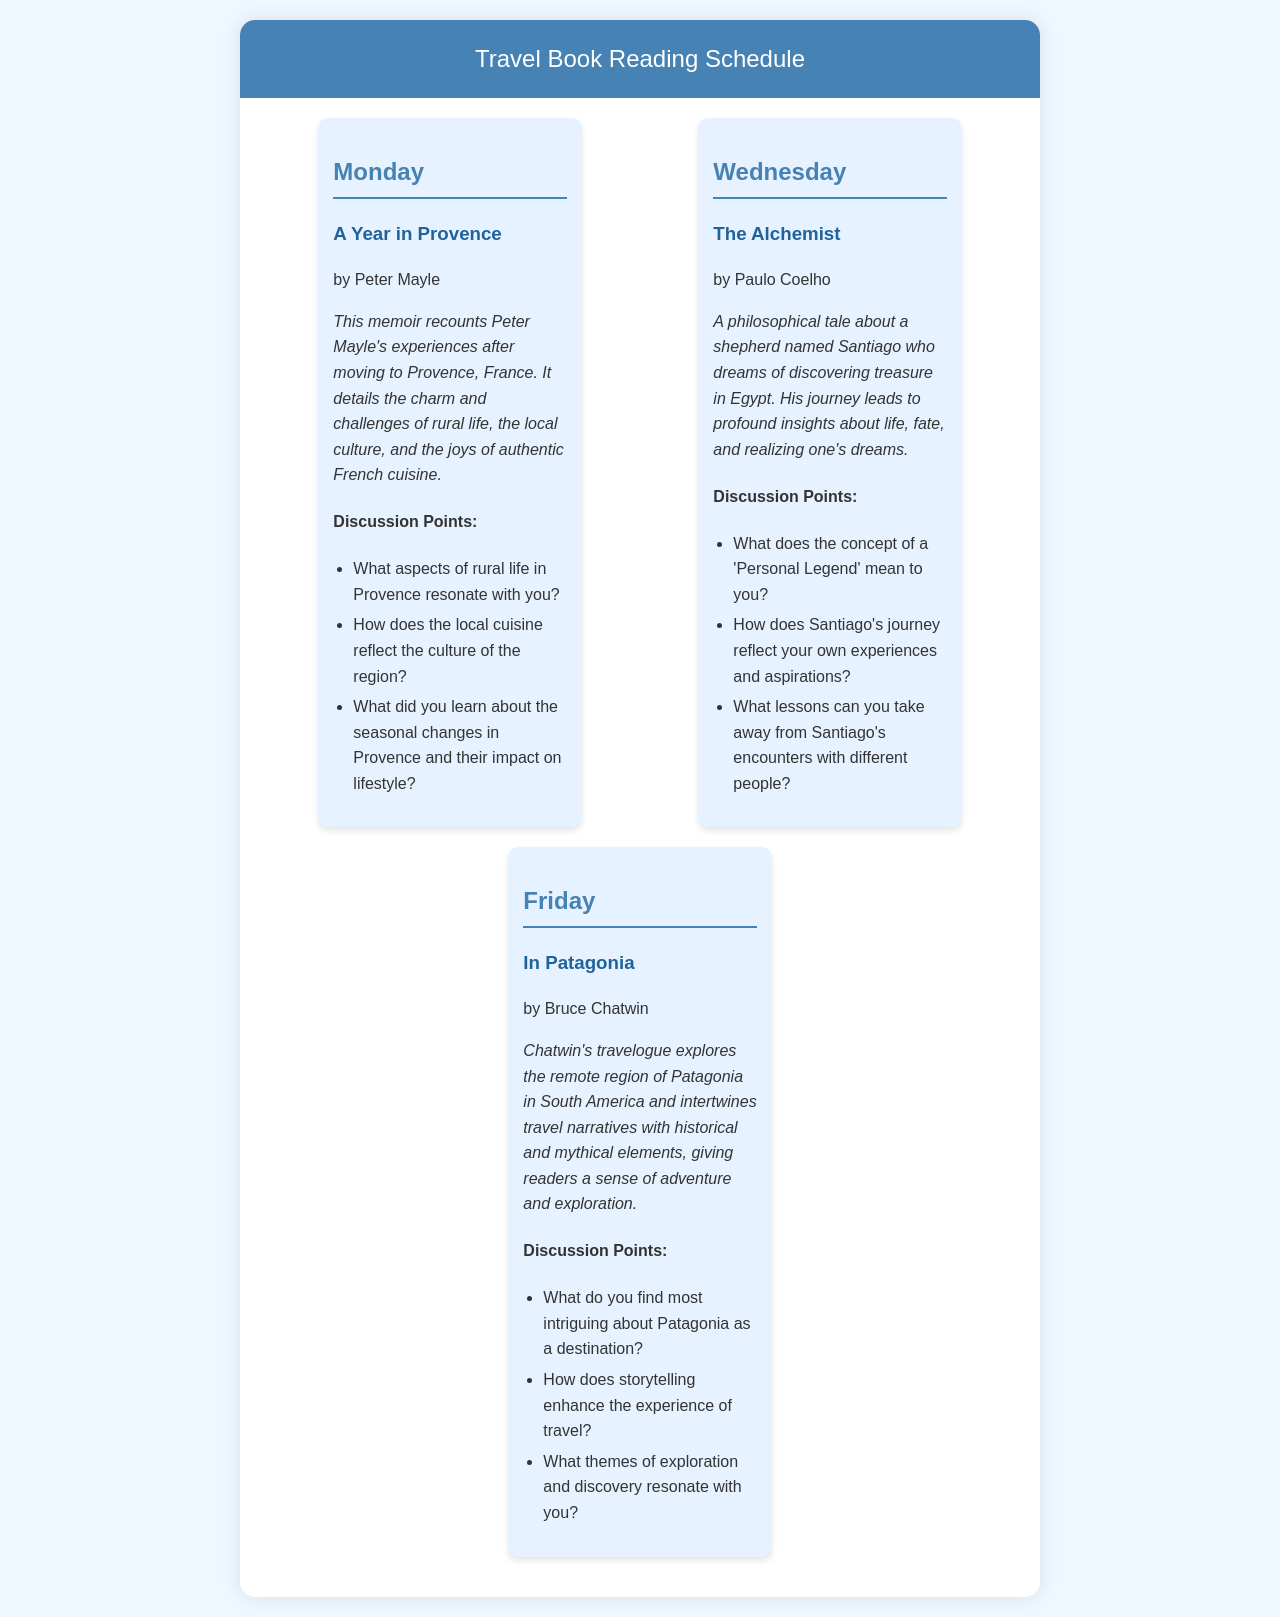What is the title of the book read on Monday? The title of the book is mentioned in the Monday section of the document.
Answer: A Year in Provence Who is the author of "The Alchemist"? The author is specified right under the title of the book in the Wednesday section.
Answer: Paulo Coelho What region does "In Patagonia" explore? The region is identified within the summary of the book in the Friday section.
Answer: Patagonia How many discussion points are provided for each book? The document lists the discussion points under each book section consistently.
Answer: Three What is the key theme discussed in "The Alchemist"? The key theme is mentioned in the summary and relates to the main character's journey.
Answer: Personal Legend Which day features a memoir about rural France? The specific day is indicated in the schedule with the corresponding book title.
Answer: Monday What does the summary of "In Patagonia" include? The summary provides insights into the elements that make up the travel narrative.
Answer: Historical and mythical elements What literary form is "A Year in Provence"? The form is identified in the title, author, and summary within the document.
Answer: Memoir What is the focus of the discussion points for the book read on Wednesday? The focus is indicated by the questions listed under the Wednesday section.
Answer: Santiago's journey and personal experiences 